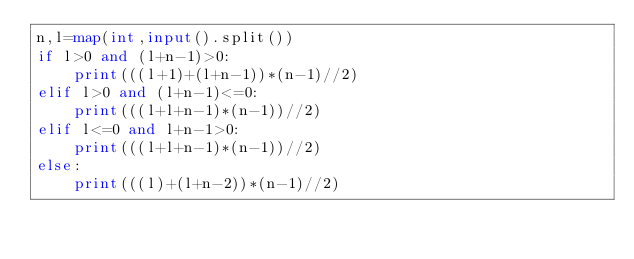<code> <loc_0><loc_0><loc_500><loc_500><_Python_>n,l=map(int,input().split())
if l>0 and (l+n-1)>0:
    print(((l+1)+(l+n-1))*(n-1)//2)
elif l>0 and (l+n-1)<=0:
    print(((l+l+n-1)*(n-1))//2)
elif l<=0 and l+n-1>0:
    print(((l+l+n-1)*(n-1))//2)
else:
    print(((l)+(l+n-2))*(n-1)//2)</code> 